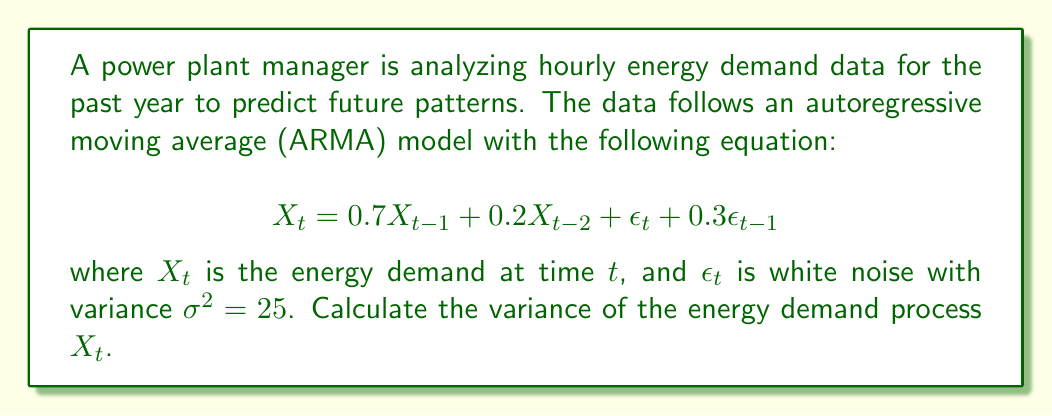Help me with this question. To calculate the variance of the ARMA(2,1) process, we'll follow these steps:

1) For an ARMA(p,q) process, the variance is given by:

   $$\gamma(0) = \frac{\sigma^2(1 + \theta_1^2 + ... + \theta_q^2)}{1 - (\phi_1\rho(1) + ... + \phi_p\rho(p))}$$

   where $\gamma(0)$ is the variance, $\sigma^2$ is the white noise variance, $\theta_i$ are the MA coefficients, $\phi_i$ are the AR coefficients, and $\rho(i)$ are the autocorrelations.

2) In our case, $p=2$, $q=1$, $\phi_1 = 0.7$, $\phi_2 = 0.2$, $\theta_1 = 0.3$, and $\sigma^2 = 25$.

3) We need to calculate $\rho(1)$ and $\rho(2)$. For an ARMA(2,1) process:

   $$\rho(1) = \frac{\phi_1}{1-\phi_2} = \frac{0.7}{1-0.2} = 0.875$$
   $$\rho(2) = \phi_1\rho(1) + \phi_2 = 0.7(0.875) + 0.2 = 0.8125$$

4) Now we can substitute these values into the variance formula:

   $$\gamma(0) = \frac{25(1 + 0.3^2)}{1 - (0.7(0.875) + 0.2(0.8125))}$$

5) Simplify:
   $$\gamma(0) = \frac{25(1.09)}{1 - (0.6125 + 0.1625)} = \frac{27.25}{0.225} = 121.11$$

Therefore, the variance of the energy demand process $X_t$ is approximately 121.11.
Answer: 121.11 